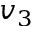Convert formula to latex. <formula><loc_0><loc_0><loc_500><loc_500>v _ { 3 }</formula> 